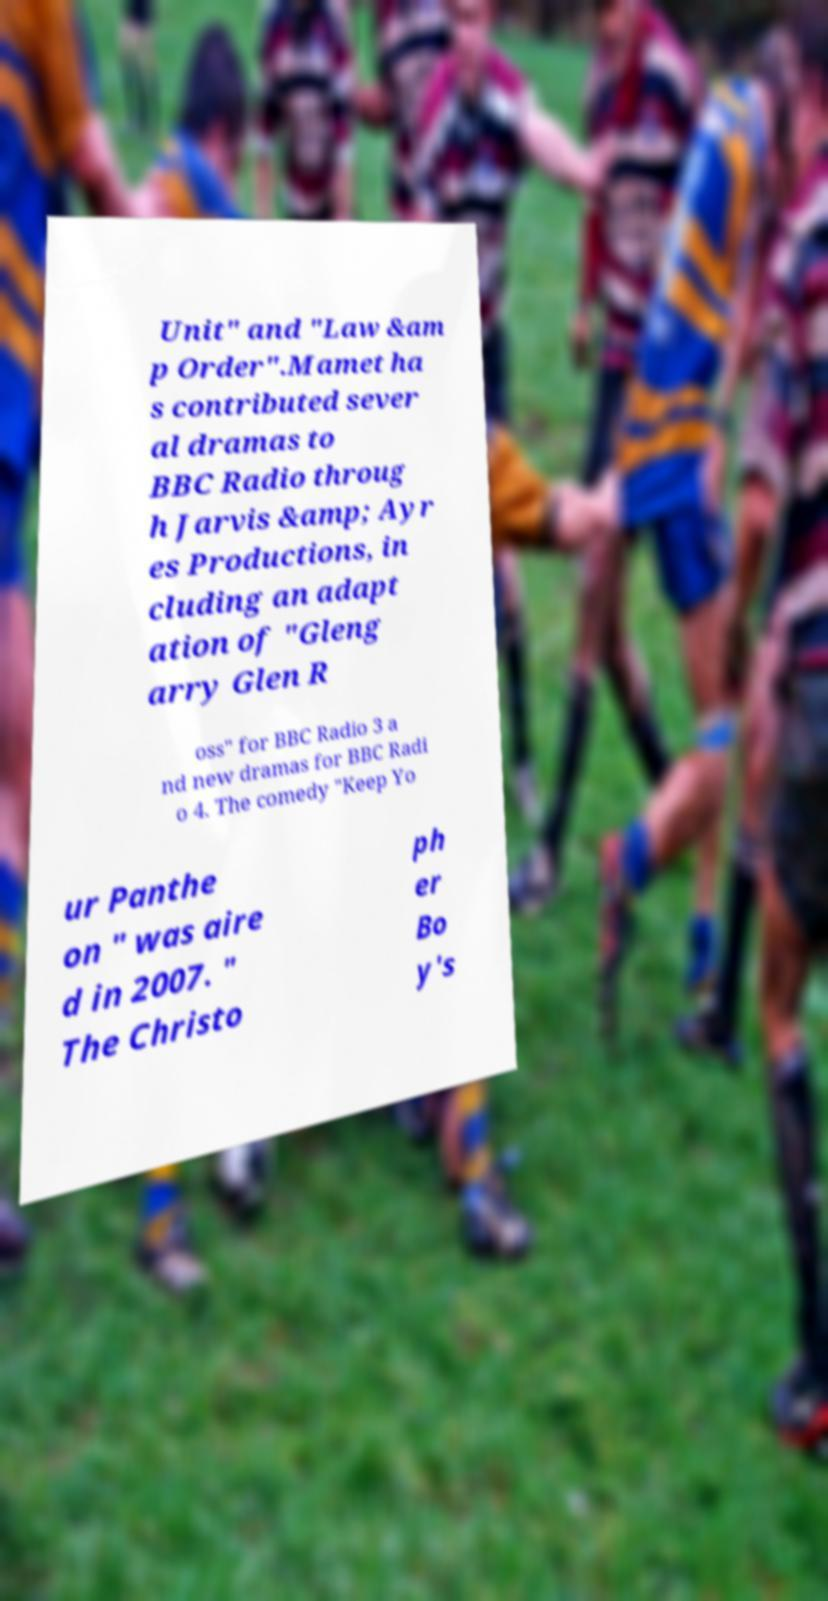For documentation purposes, I need the text within this image transcribed. Could you provide that? Unit" and "Law &am p Order".Mamet ha s contributed sever al dramas to BBC Radio throug h Jarvis &amp; Ayr es Productions, in cluding an adapt ation of "Gleng arry Glen R oss" for BBC Radio 3 a nd new dramas for BBC Radi o 4. The comedy "Keep Yo ur Panthe on " was aire d in 2007. " The Christo ph er Bo y's 